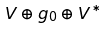Convert formula to latex. <formula><loc_0><loc_0><loc_500><loc_500>V \oplus g _ { 0 } \oplus V ^ { * }</formula> 